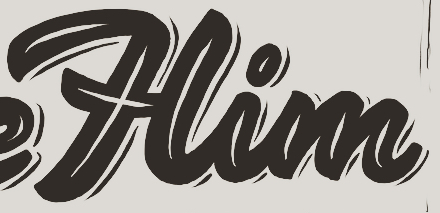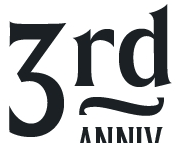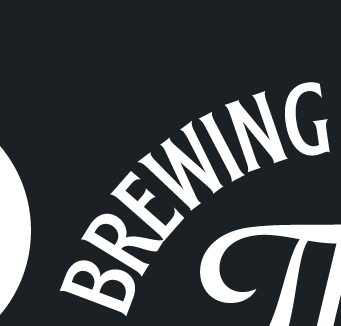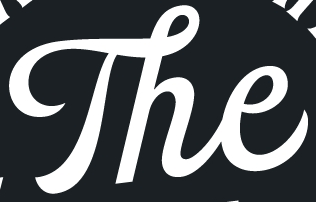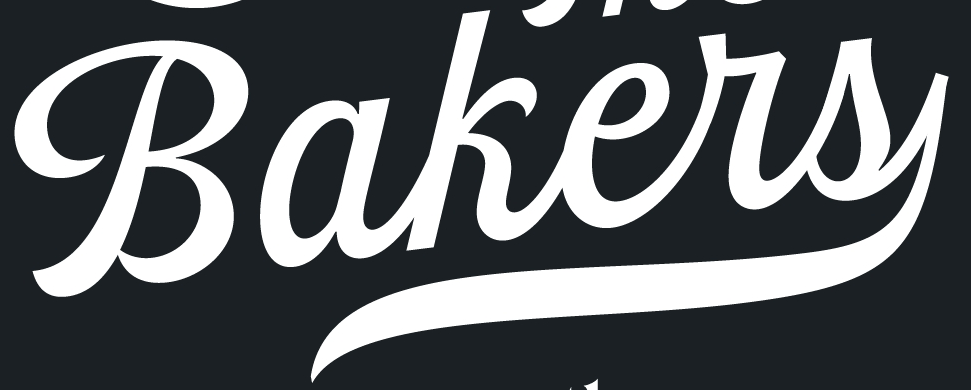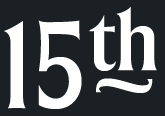What text is displayed in these images sequentially, separated by a semicolon? Him; 3rd; BREWING; The; Bakers; 15th 